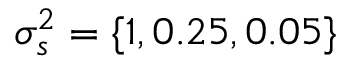<formula> <loc_0><loc_0><loc_500><loc_500>\sigma _ { s } ^ { 2 } = \{ 1 , 0 . 2 5 , 0 . 0 5 \}</formula> 